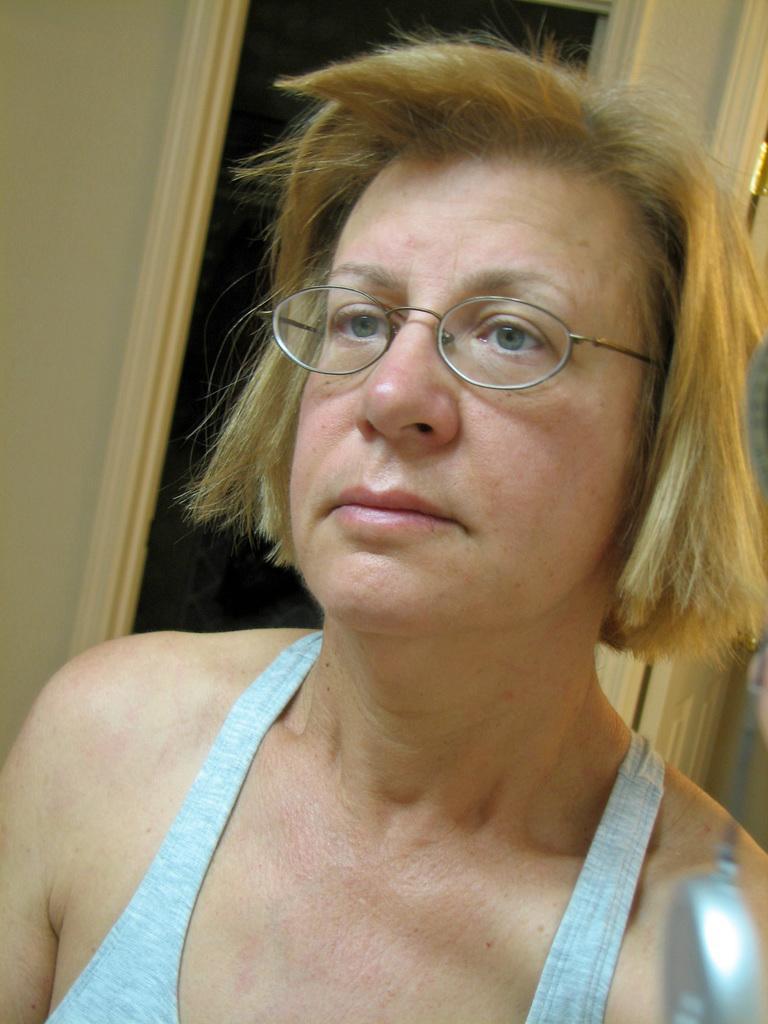Can you describe this image briefly? This picture shows a woman. She wore spectacles on her face and we see a door. 